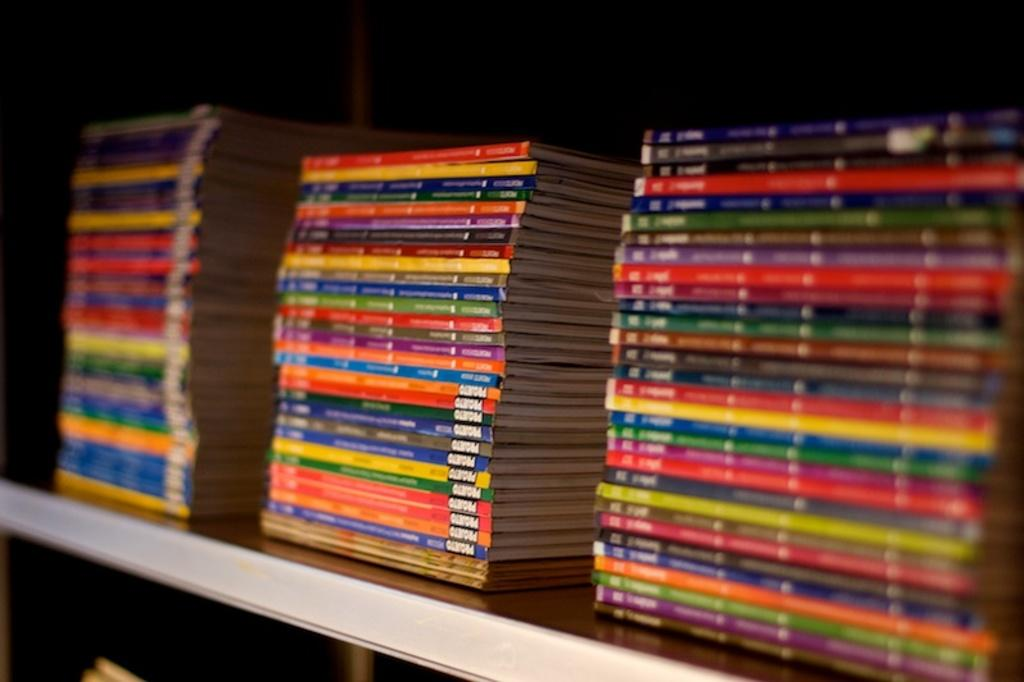What type of picture is the image? The image is a zoomed in picture. What can be seen in the image? There are many books in the image. How are the books arranged in the image? The books are placed on a wooden rack. Can you see any horses in the image? No, there are no horses present in the image. Is there any mist visible in the image? No, there is no mist visible in the image. 